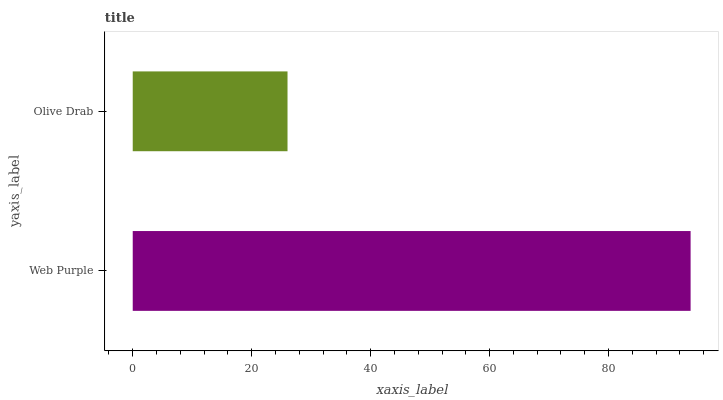Is Olive Drab the minimum?
Answer yes or no. Yes. Is Web Purple the maximum?
Answer yes or no. Yes. Is Olive Drab the maximum?
Answer yes or no. No. Is Web Purple greater than Olive Drab?
Answer yes or no. Yes. Is Olive Drab less than Web Purple?
Answer yes or no. Yes. Is Olive Drab greater than Web Purple?
Answer yes or no. No. Is Web Purple less than Olive Drab?
Answer yes or no. No. Is Web Purple the high median?
Answer yes or no. Yes. Is Olive Drab the low median?
Answer yes or no. Yes. Is Olive Drab the high median?
Answer yes or no. No. Is Web Purple the low median?
Answer yes or no. No. 